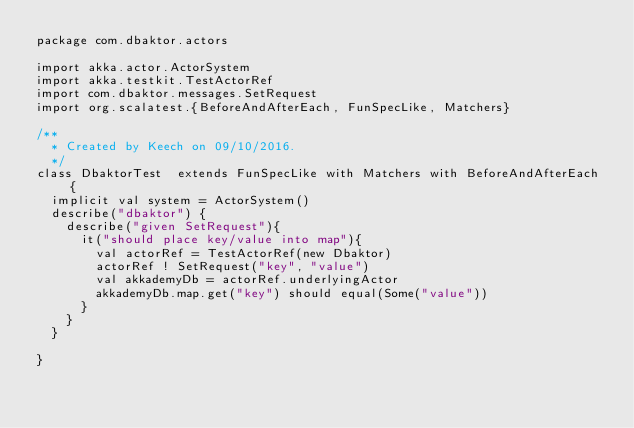Convert code to text. <code><loc_0><loc_0><loc_500><loc_500><_Scala_>package com.dbaktor.actors

import akka.actor.ActorSystem
import akka.testkit.TestActorRef
import com.dbaktor.messages.SetRequest
import org.scalatest.{BeforeAndAfterEach, FunSpecLike, Matchers}

/**
  * Created by Keech on 09/10/2016.
  */
class DbaktorTest  extends FunSpecLike with Matchers with BeforeAndAfterEach {
  implicit val system = ActorSystem()
  describe("dbaktor") {
    describe("given SetRequest"){
      it("should place key/value into map"){
        val actorRef = TestActorRef(new Dbaktor)
        actorRef ! SetRequest("key", "value")
        val akkademyDb = actorRef.underlyingActor
        akkademyDb.map.get("key") should equal(Some("value"))
      }
    }
  }

}
</code> 